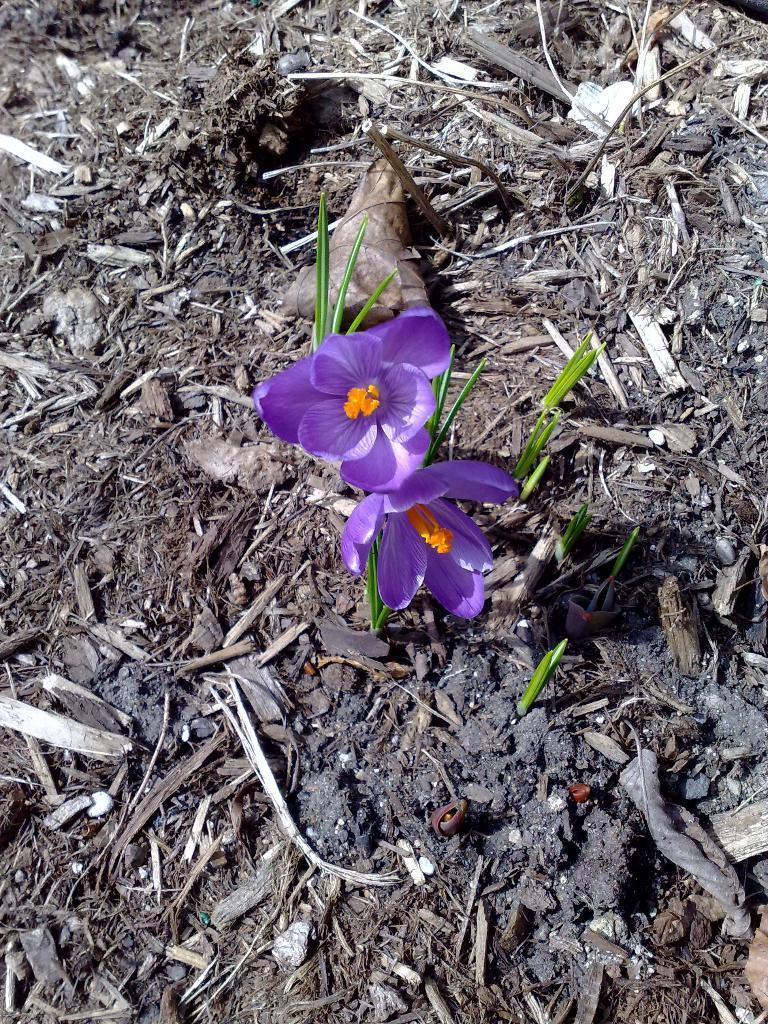Please provide a concise description of this image. In the image we can see two flowers, purple and pale orange in colour. There are leaves and pieces of wood. 